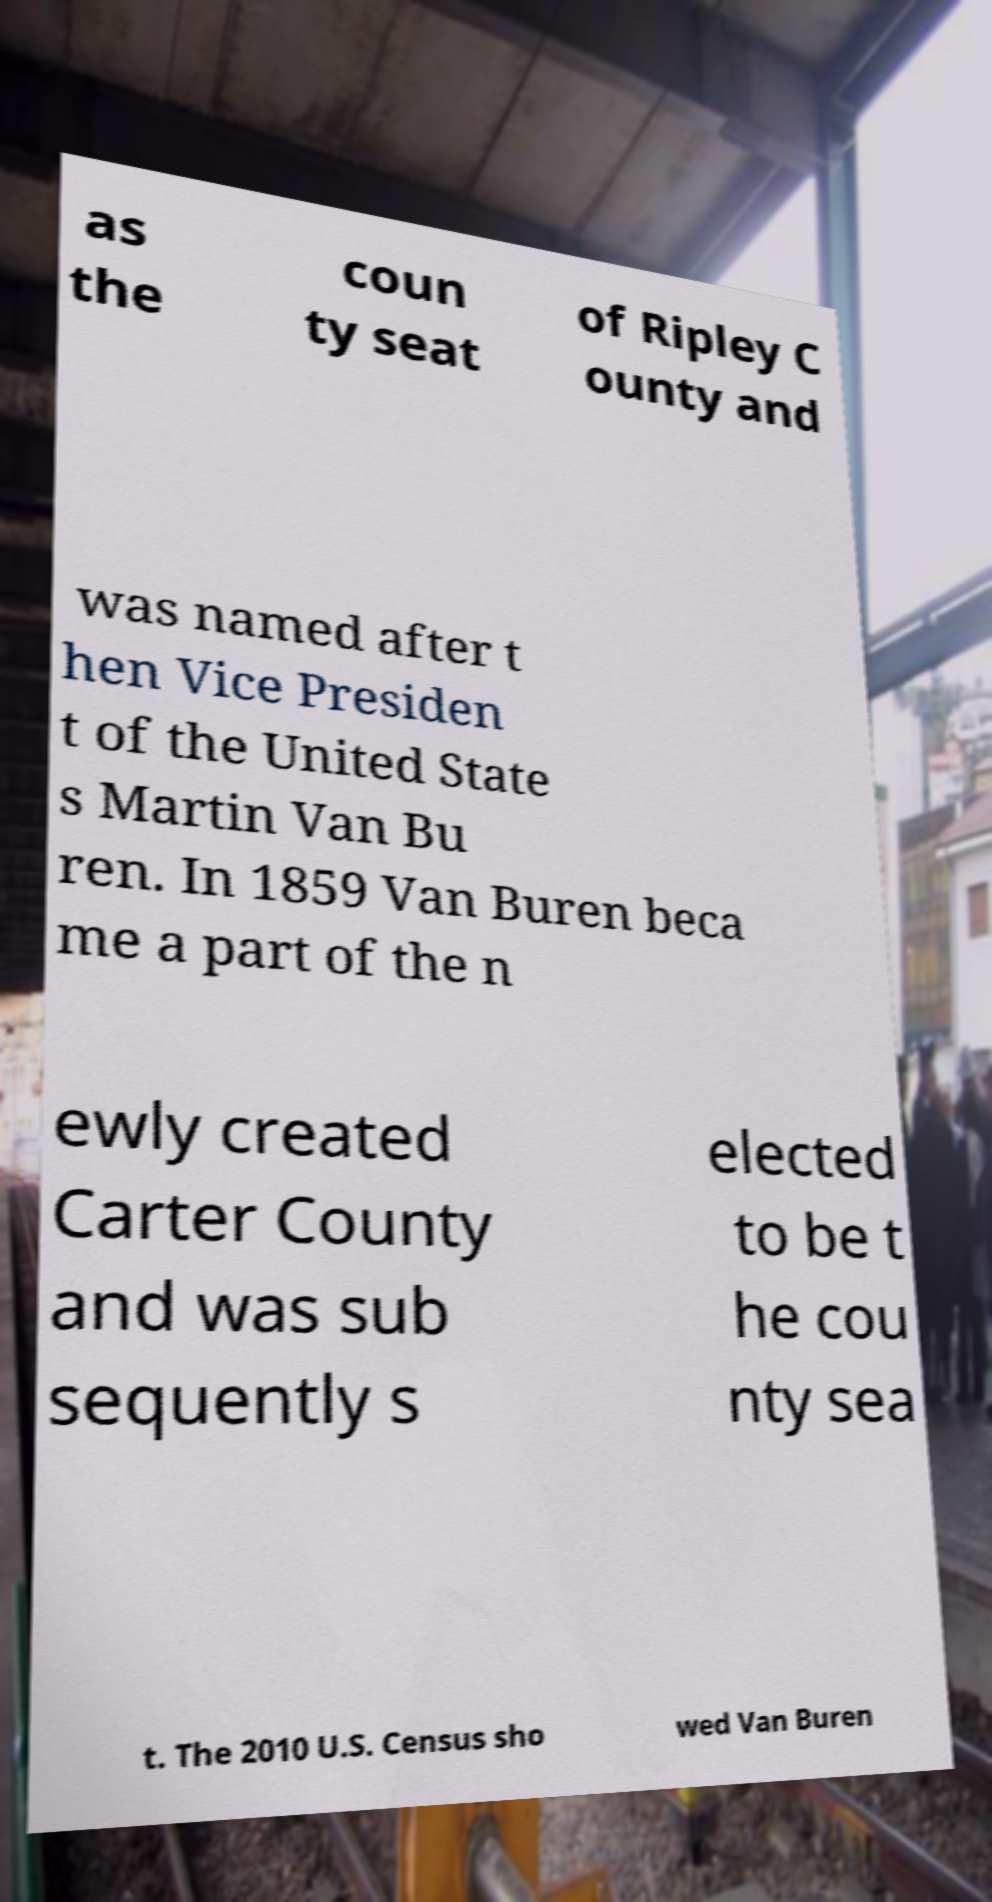Could you extract and type out the text from this image? as the coun ty seat of Ripley C ounty and was named after t hen Vice Presiden t of the United State s Martin Van Bu ren. In 1859 Van Buren beca me a part of the n ewly created Carter County and was sub sequently s elected to be t he cou nty sea t. The 2010 U.S. Census sho wed Van Buren 